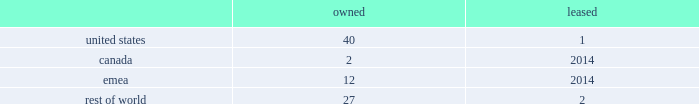Volatility of capital markets or macroeconomic factors could adversely affect our business .
Changes in financial and capital markets , including market disruptions , limited liquidity , uncertainty regarding brexit , and interest rate volatility , including as a result of the use or discontinued use of certain benchmark rates such as libor , may increase the cost of financing as well as the risks of refinancing maturing debt .
In addition , our borrowing costs can be affected by short and long-term ratings assigned by rating organizations .
A decrease in these ratings could limit our access to capital markets and increase our borrowing costs , which could materially and adversely affect our financial condition and operating results .
Some of our customers and counterparties are highly leveraged .
Consolidations in some of the industries in which our customers operate have created larger customers , some of which are highly leveraged and facing increased competition and continued credit market volatility .
These factors have caused some customers to be less profitable , increasing our exposure to credit risk .
A significant adverse change in the financial and/or credit position of a customer or counterparty could require us to assume greater credit risk relating to that customer or counterparty and could limit our ability to collect receivables .
This could have an adverse impact on our financial condition and liquidity .
Item 1b .
Unresolved staff comments .
Item 2 .
Properties .
Our corporate co-headquarters are located in pittsburgh , pennsylvania and chicago , illinois .
Our co-headquarters are leased and house certain executive offices , our u.s .
Business units , and our administrative , finance , legal , and human resource functions .
We maintain additional owned and leased offices throughout the regions in which we operate .
We manufacture our products in our network of manufacturing and processing facilities located throughout the world .
As of december 29 , 2018 , we operated 84 manufacturing and processing facilities .
We own 81 and lease three of these facilities .
Our manufacturing and processing facilities count by segment as of december 29 , 2018 was: .
We maintain all of our manufacturing and processing facilities in good condition and believe they are suitable and are adequate for our present needs .
We also enter into co-manufacturing arrangements with third parties if we determine it is advantageous to outsource the production of any of our products .
In the fourth quarter of 2018 , we announced our plans to divest certain assets and operations , predominantly in canada and india , including one owned manufacturing facility in canada and one owned and one leased facility in india .
See note 5 , acquisitions and divestitures , in item 8 , financial statements and supplementary data , for additional information on these transactions .
Item 3 .
Legal proceedings .
See note 18 , commitments and contingencies , in item 8 , financial statements and supplementary data .
Item 4 .
Mine safety disclosures .
Not applicable .
Part ii item 5 .
Market for registrant's common equity , related stockholder matters and issuer purchases of equity securities .
Our common stock is listed on nasdaq under the ticker symbol 201ckhc 201d .
At june 5 , 2019 , there were approximately 49000 holders of record of our common stock .
See equity and dividends in item 7 , management 2019s discussion and analysis of financial condition and results of operations , for a discussion of cash dividends declared on our common stock. .
What percent of facilities are leased? 
Computations: (3 / 84)
Answer: 0.03571. 